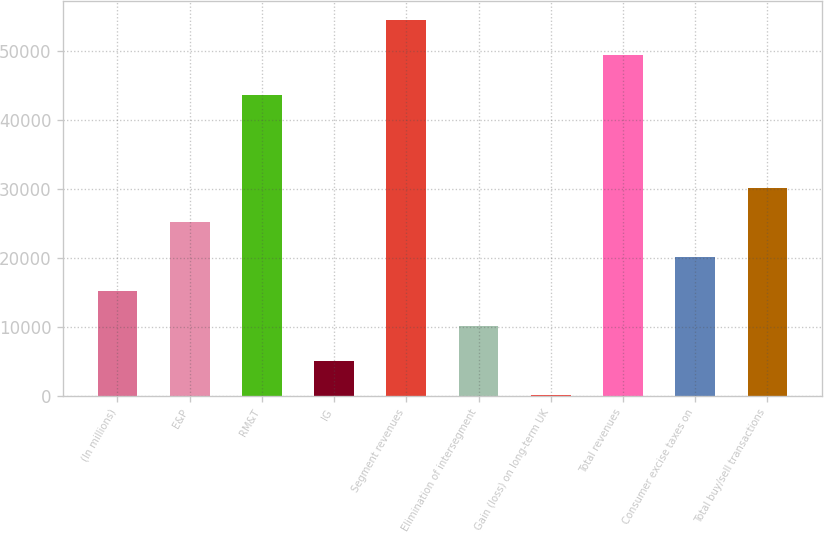<chart> <loc_0><loc_0><loc_500><loc_500><bar_chart><fcel>(In millions)<fcel>E&P<fcel>RM&T<fcel>IG<fcel>Segment revenues<fcel>Elimination of intersegment<fcel>Gain (loss) on long-term UK<fcel>Total revenues<fcel>Consumer excise taxes on<fcel>Total buy/sell transactions<nl><fcel>15138.9<fcel>25165.5<fcel>43630<fcel>5112.3<fcel>54478.3<fcel>10125.6<fcel>99<fcel>49465<fcel>20152.2<fcel>30178.8<nl></chart> 